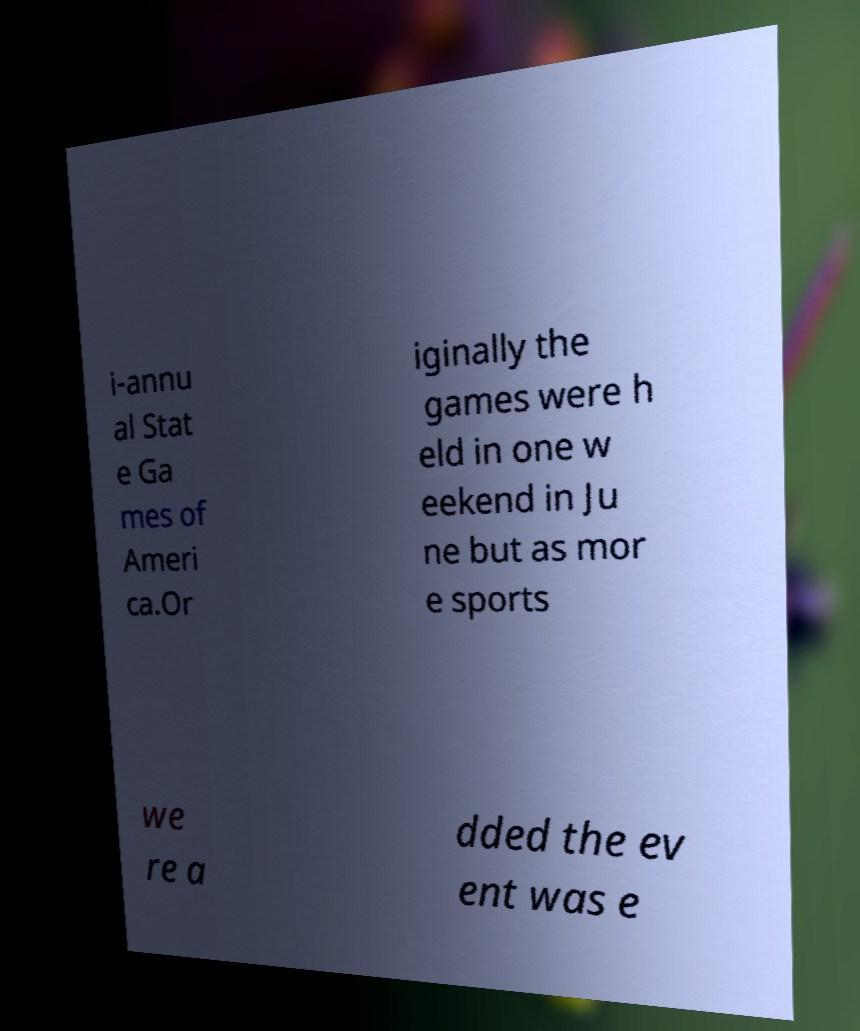Could you assist in decoding the text presented in this image and type it out clearly? i-annu al Stat e Ga mes of Ameri ca.Or iginally the games were h eld in one w eekend in Ju ne but as mor e sports we re a dded the ev ent was e 